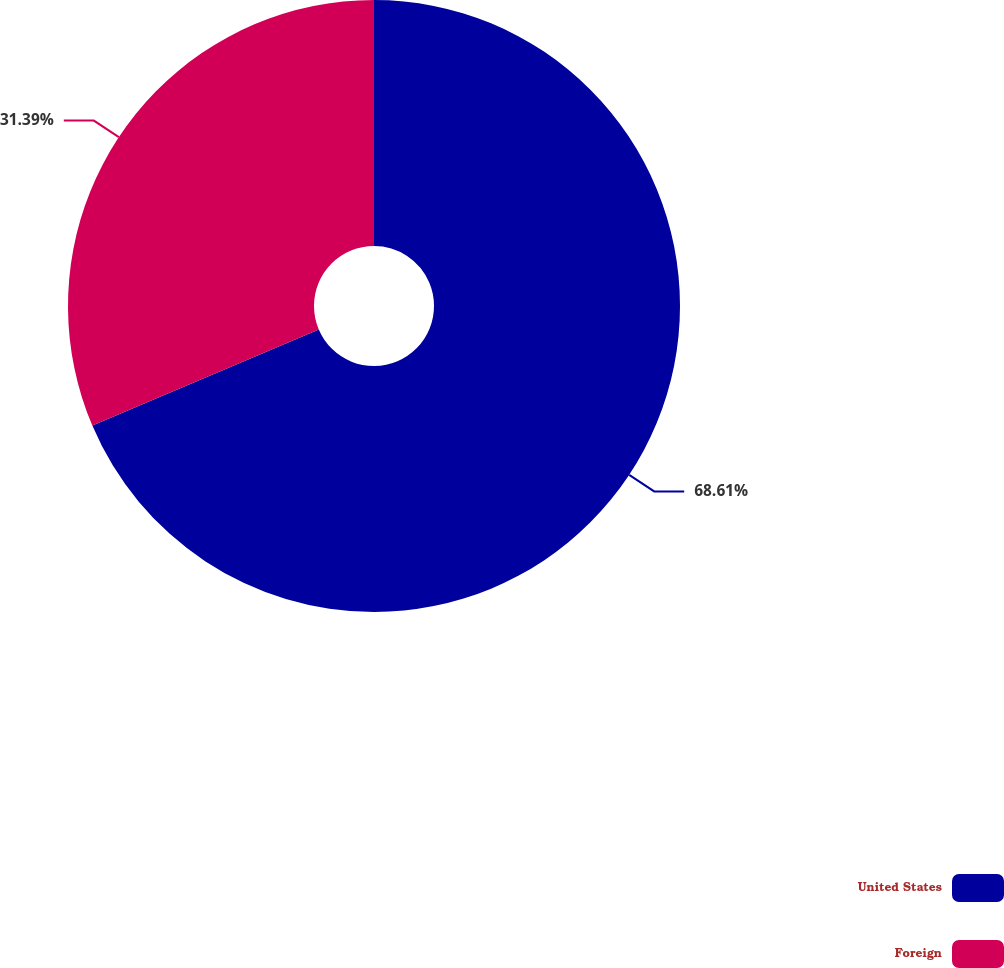<chart> <loc_0><loc_0><loc_500><loc_500><pie_chart><fcel>United States<fcel>Foreign<nl><fcel>68.61%<fcel>31.39%<nl></chart> 